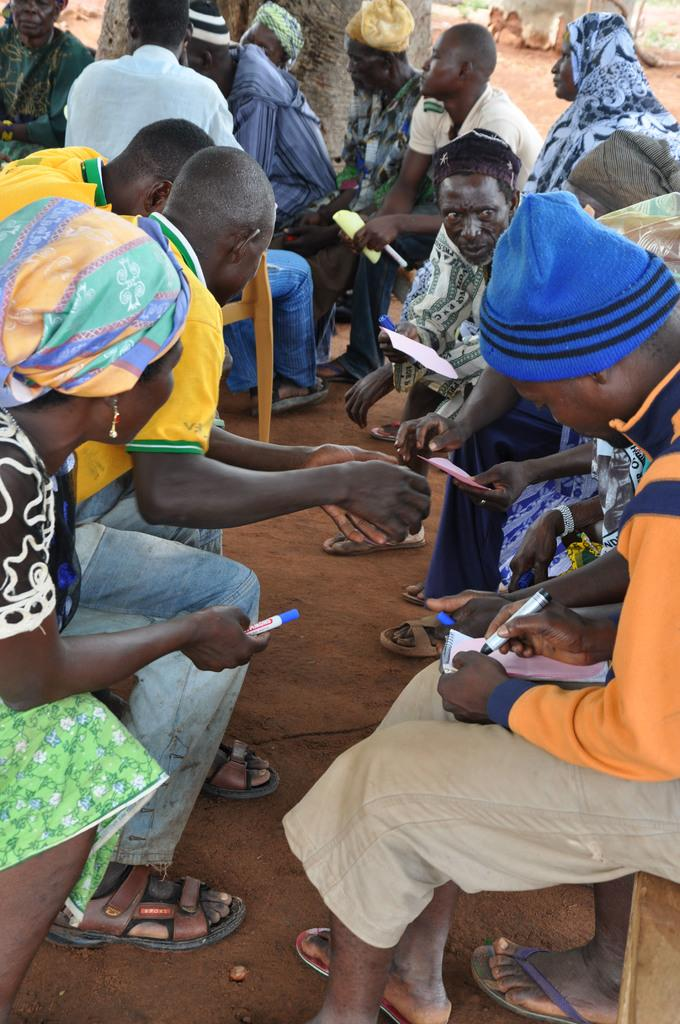Where are the groups of people located in the image? There is a group of people on the right side of the image and another group on the left side of the image. What are the people holding in their hands? The people are holding papers in their hands. What can be seen at the top side of the image? There is a tree at the top side of the image. What type of joke is being told by the person on the left side of the image? There is no person telling a joke in the image, nor is there any indication of a joke being told. 